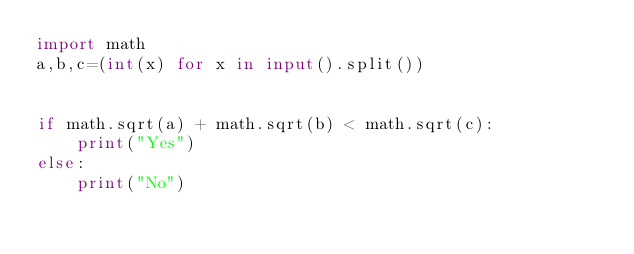Convert code to text. <code><loc_0><loc_0><loc_500><loc_500><_Python_>import math
a,b,c=(int(x) for x in input().split())


if math.sqrt(a) + math.sqrt(b) < math.sqrt(c):
    print("Yes")
else:
    print("No")</code> 